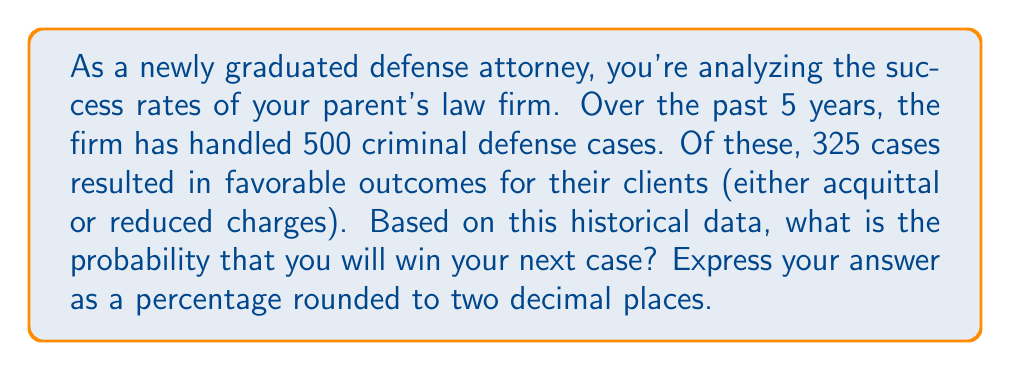Provide a solution to this math problem. To solve this problem, we need to use the concept of relative frequency as an estimate of probability. The relative frequency of an event is calculated by dividing the number of favorable outcomes by the total number of trials.

Let's define our variables:
$n$ = total number of cases = 500
$x$ = number of favorable outcomes = 325

The probability of winning a case can be estimated as:

$$ P(\text{winning}) = \frac{\text{number of favorable outcomes}}{\text{total number of cases}} = \frac{x}{n} $$

Plugging in our values:

$$ P(\text{winning}) = \frac{325}{500} = 0.65 $$

To express this as a percentage, we multiply by 100:

$$ 0.65 \times 100 = 65\% $$

Therefore, based on the historical data, the probability of winning your next case is 65.00%.
Answer: 65.00% 